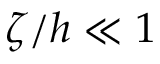<formula> <loc_0><loc_0><loc_500><loc_500>\zeta / h \ll 1</formula> 